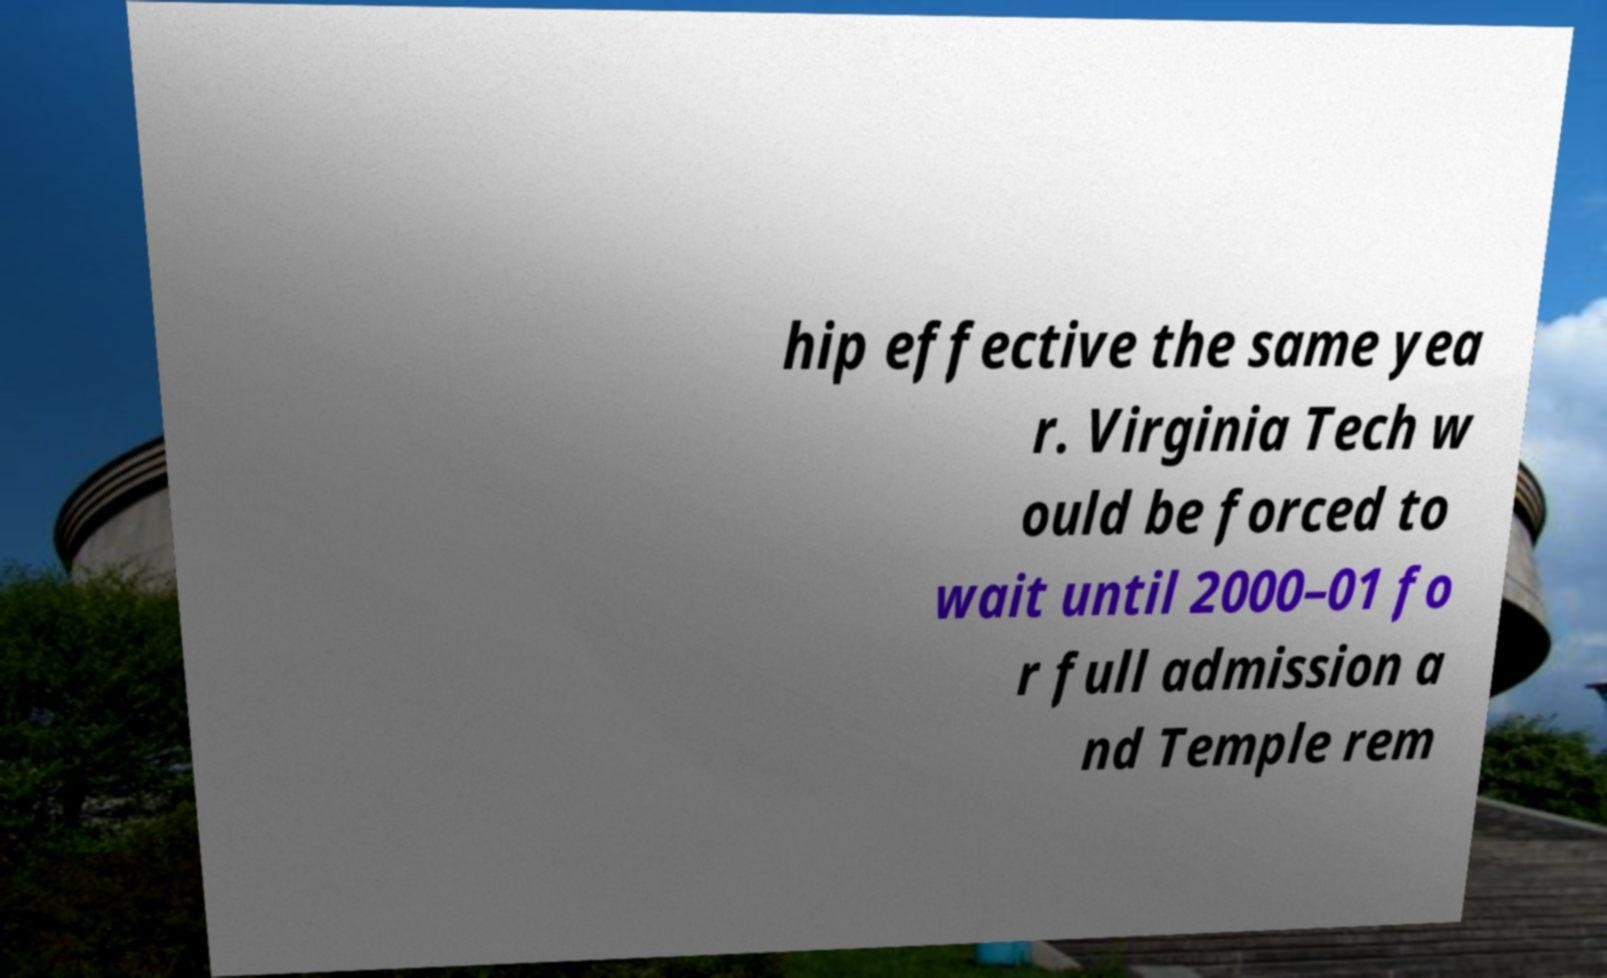Can you read and provide the text displayed in the image?This photo seems to have some interesting text. Can you extract and type it out for me? hip effective the same yea r. Virginia Tech w ould be forced to wait until 2000–01 fo r full admission a nd Temple rem 